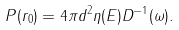Convert formula to latex. <formula><loc_0><loc_0><loc_500><loc_500>P ( { r _ { 0 } } ) = 4 \pi d ^ { 2 } \eta ( E ) D ^ { - 1 } ( \omega ) .</formula> 